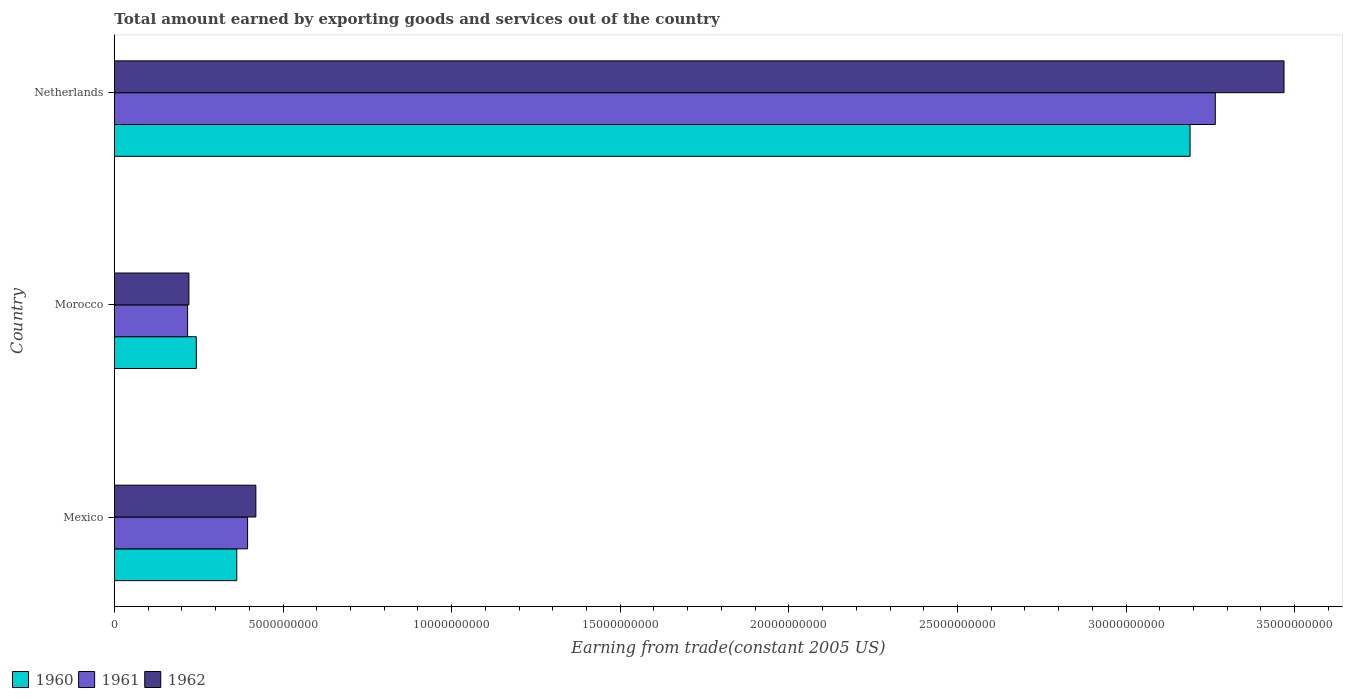How many groups of bars are there?
Ensure brevity in your answer.  3. Are the number of bars per tick equal to the number of legend labels?
Keep it short and to the point. Yes. How many bars are there on the 1st tick from the bottom?
Give a very brief answer. 3. What is the label of the 1st group of bars from the top?
Make the answer very short. Netherlands. In how many cases, is the number of bars for a given country not equal to the number of legend labels?
Offer a terse response. 0. What is the total amount earned by exporting goods and services in 1961 in Netherlands?
Your answer should be very brief. 3.26e+1. Across all countries, what is the maximum total amount earned by exporting goods and services in 1962?
Offer a terse response. 3.47e+1. Across all countries, what is the minimum total amount earned by exporting goods and services in 1960?
Ensure brevity in your answer.  2.43e+09. In which country was the total amount earned by exporting goods and services in 1960 minimum?
Your response must be concise. Morocco. What is the total total amount earned by exporting goods and services in 1961 in the graph?
Ensure brevity in your answer.  3.88e+1. What is the difference between the total amount earned by exporting goods and services in 1961 in Mexico and that in Netherlands?
Offer a terse response. -2.87e+1. What is the difference between the total amount earned by exporting goods and services in 1960 in Netherlands and the total amount earned by exporting goods and services in 1962 in Morocco?
Offer a terse response. 2.97e+1. What is the average total amount earned by exporting goods and services in 1962 per country?
Give a very brief answer. 1.37e+1. What is the difference between the total amount earned by exporting goods and services in 1960 and total amount earned by exporting goods and services in 1962 in Morocco?
Your response must be concise. 2.19e+08. In how many countries, is the total amount earned by exporting goods and services in 1960 greater than 23000000000 US$?
Offer a very short reply. 1. What is the ratio of the total amount earned by exporting goods and services in 1961 in Morocco to that in Netherlands?
Offer a very short reply. 0.07. Is the total amount earned by exporting goods and services in 1961 in Morocco less than that in Netherlands?
Your answer should be compact. Yes. Is the difference between the total amount earned by exporting goods and services in 1960 in Morocco and Netherlands greater than the difference between the total amount earned by exporting goods and services in 1962 in Morocco and Netherlands?
Give a very brief answer. Yes. What is the difference between the highest and the second highest total amount earned by exporting goods and services in 1962?
Your answer should be compact. 3.05e+1. What is the difference between the highest and the lowest total amount earned by exporting goods and services in 1960?
Make the answer very short. 2.95e+1. In how many countries, is the total amount earned by exporting goods and services in 1960 greater than the average total amount earned by exporting goods and services in 1960 taken over all countries?
Your response must be concise. 1. Is the sum of the total amount earned by exporting goods and services in 1960 in Morocco and Netherlands greater than the maximum total amount earned by exporting goods and services in 1961 across all countries?
Your answer should be compact. Yes. What does the 1st bar from the top in Morocco represents?
Offer a terse response. 1962. Is it the case that in every country, the sum of the total amount earned by exporting goods and services in 1960 and total amount earned by exporting goods and services in 1961 is greater than the total amount earned by exporting goods and services in 1962?
Provide a succinct answer. Yes. How many bars are there?
Offer a very short reply. 9. Are all the bars in the graph horizontal?
Your answer should be compact. Yes. Does the graph contain any zero values?
Make the answer very short. No. Does the graph contain grids?
Give a very brief answer. No. Where does the legend appear in the graph?
Your answer should be compact. Bottom left. How many legend labels are there?
Ensure brevity in your answer.  3. How are the legend labels stacked?
Make the answer very short. Horizontal. What is the title of the graph?
Make the answer very short. Total amount earned by exporting goods and services out of the country. Does "1992" appear as one of the legend labels in the graph?
Your answer should be very brief. No. What is the label or title of the X-axis?
Offer a terse response. Earning from trade(constant 2005 US). What is the label or title of the Y-axis?
Ensure brevity in your answer.  Country. What is the Earning from trade(constant 2005 US) in 1960 in Mexico?
Keep it short and to the point. 3.63e+09. What is the Earning from trade(constant 2005 US) in 1961 in Mexico?
Your response must be concise. 3.95e+09. What is the Earning from trade(constant 2005 US) of 1962 in Mexico?
Your answer should be compact. 4.19e+09. What is the Earning from trade(constant 2005 US) in 1960 in Morocco?
Your answer should be compact. 2.43e+09. What is the Earning from trade(constant 2005 US) of 1961 in Morocco?
Provide a short and direct response. 2.17e+09. What is the Earning from trade(constant 2005 US) in 1962 in Morocco?
Make the answer very short. 2.21e+09. What is the Earning from trade(constant 2005 US) in 1960 in Netherlands?
Keep it short and to the point. 3.19e+1. What is the Earning from trade(constant 2005 US) of 1961 in Netherlands?
Your answer should be compact. 3.26e+1. What is the Earning from trade(constant 2005 US) of 1962 in Netherlands?
Make the answer very short. 3.47e+1. Across all countries, what is the maximum Earning from trade(constant 2005 US) in 1960?
Offer a very short reply. 3.19e+1. Across all countries, what is the maximum Earning from trade(constant 2005 US) of 1961?
Make the answer very short. 3.26e+1. Across all countries, what is the maximum Earning from trade(constant 2005 US) in 1962?
Offer a very short reply. 3.47e+1. Across all countries, what is the minimum Earning from trade(constant 2005 US) of 1960?
Provide a succinct answer. 2.43e+09. Across all countries, what is the minimum Earning from trade(constant 2005 US) in 1961?
Your answer should be very brief. 2.17e+09. Across all countries, what is the minimum Earning from trade(constant 2005 US) of 1962?
Keep it short and to the point. 2.21e+09. What is the total Earning from trade(constant 2005 US) of 1960 in the graph?
Make the answer very short. 3.80e+1. What is the total Earning from trade(constant 2005 US) in 1961 in the graph?
Keep it short and to the point. 3.88e+1. What is the total Earning from trade(constant 2005 US) in 1962 in the graph?
Offer a very short reply. 4.11e+1. What is the difference between the Earning from trade(constant 2005 US) of 1960 in Mexico and that in Morocco?
Your answer should be very brief. 1.20e+09. What is the difference between the Earning from trade(constant 2005 US) in 1961 in Mexico and that in Morocco?
Ensure brevity in your answer.  1.78e+09. What is the difference between the Earning from trade(constant 2005 US) of 1962 in Mexico and that in Morocco?
Your response must be concise. 1.99e+09. What is the difference between the Earning from trade(constant 2005 US) in 1960 in Mexico and that in Netherlands?
Provide a succinct answer. -2.83e+1. What is the difference between the Earning from trade(constant 2005 US) in 1961 in Mexico and that in Netherlands?
Provide a succinct answer. -2.87e+1. What is the difference between the Earning from trade(constant 2005 US) of 1962 in Mexico and that in Netherlands?
Offer a terse response. -3.05e+1. What is the difference between the Earning from trade(constant 2005 US) of 1960 in Morocco and that in Netherlands?
Ensure brevity in your answer.  -2.95e+1. What is the difference between the Earning from trade(constant 2005 US) in 1961 in Morocco and that in Netherlands?
Offer a terse response. -3.05e+1. What is the difference between the Earning from trade(constant 2005 US) of 1962 in Morocco and that in Netherlands?
Provide a short and direct response. -3.25e+1. What is the difference between the Earning from trade(constant 2005 US) in 1960 in Mexico and the Earning from trade(constant 2005 US) in 1961 in Morocco?
Give a very brief answer. 1.46e+09. What is the difference between the Earning from trade(constant 2005 US) of 1960 in Mexico and the Earning from trade(constant 2005 US) of 1962 in Morocco?
Your answer should be very brief. 1.42e+09. What is the difference between the Earning from trade(constant 2005 US) of 1961 in Mexico and the Earning from trade(constant 2005 US) of 1962 in Morocco?
Offer a very short reply. 1.74e+09. What is the difference between the Earning from trade(constant 2005 US) of 1960 in Mexico and the Earning from trade(constant 2005 US) of 1961 in Netherlands?
Offer a very short reply. -2.90e+1. What is the difference between the Earning from trade(constant 2005 US) in 1960 in Mexico and the Earning from trade(constant 2005 US) in 1962 in Netherlands?
Provide a succinct answer. -3.11e+1. What is the difference between the Earning from trade(constant 2005 US) of 1961 in Mexico and the Earning from trade(constant 2005 US) of 1962 in Netherlands?
Ensure brevity in your answer.  -3.07e+1. What is the difference between the Earning from trade(constant 2005 US) of 1960 in Morocco and the Earning from trade(constant 2005 US) of 1961 in Netherlands?
Give a very brief answer. -3.02e+1. What is the difference between the Earning from trade(constant 2005 US) in 1960 in Morocco and the Earning from trade(constant 2005 US) in 1962 in Netherlands?
Give a very brief answer. -3.23e+1. What is the difference between the Earning from trade(constant 2005 US) of 1961 in Morocco and the Earning from trade(constant 2005 US) of 1962 in Netherlands?
Ensure brevity in your answer.  -3.25e+1. What is the average Earning from trade(constant 2005 US) in 1960 per country?
Your answer should be very brief. 1.27e+1. What is the average Earning from trade(constant 2005 US) in 1961 per country?
Make the answer very short. 1.29e+1. What is the average Earning from trade(constant 2005 US) in 1962 per country?
Offer a very short reply. 1.37e+1. What is the difference between the Earning from trade(constant 2005 US) in 1960 and Earning from trade(constant 2005 US) in 1961 in Mexico?
Give a very brief answer. -3.21e+08. What is the difference between the Earning from trade(constant 2005 US) in 1960 and Earning from trade(constant 2005 US) in 1962 in Mexico?
Your answer should be very brief. -5.66e+08. What is the difference between the Earning from trade(constant 2005 US) of 1961 and Earning from trade(constant 2005 US) of 1962 in Mexico?
Your answer should be very brief. -2.45e+08. What is the difference between the Earning from trade(constant 2005 US) in 1960 and Earning from trade(constant 2005 US) in 1961 in Morocco?
Offer a very short reply. 2.59e+08. What is the difference between the Earning from trade(constant 2005 US) of 1960 and Earning from trade(constant 2005 US) of 1962 in Morocco?
Give a very brief answer. 2.19e+08. What is the difference between the Earning from trade(constant 2005 US) of 1961 and Earning from trade(constant 2005 US) of 1962 in Morocco?
Provide a succinct answer. -3.93e+07. What is the difference between the Earning from trade(constant 2005 US) in 1960 and Earning from trade(constant 2005 US) in 1961 in Netherlands?
Ensure brevity in your answer.  -7.48e+08. What is the difference between the Earning from trade(constant 2005 US) in 1960 and Earning from trade(constant 2005 US) in 1962 in Netherlands?
Make the answer very short. -2.79e+09. What is the difference between the Earning from trade(constant 2005 US) in 1961 and Earning from trade(constant 2005 US) in 1962 in Netherlands?
Your answer should be compact. -2.04e+09. What is the ratio of the Earning from trade(constant 2005 US) of 1960 in Mexico to that in Morocco?
Make the answer very short. 1.49. What is the ratio of the Earning from trade(constant 2005 US) in 1961 in Mexico to that in Morocco?
Provide a succinct answer. 1.82. What is the ratio of the Earning from trade(constant 2005 US) in 1962 in Mexico to that in Morocco?
Give a very brief answer. 1.9. What is the ratio of the Earning from trade(constant 2005 US) in 1960 in Mexico to that in Netherlands?
Your answer should be compact. 0.11. What is the ratio of the Earning from trade(constant 2005 US) of 1961 in Mexico to that in Netherlands?
Make the answer very short. 0.12. What is the ratio of the Earning from trade(constant 2005 US) in 1962 in Mexico to that in Netherlands?
Give a very brief answer. 0.12. What is the ratio of the Earning from trade(constant 2005 US) of 1960 in Morocco to that in Netherlands?
Offer a terse response. 0.08. What is the ratio of the Earning from trade(constant 2005 US) in 1961 in Morocco to that in Netherlands?
Your answer should be very brief. 0.07. What is the ratio of the Earning from trade(constant 2005 US) of 1962 in Morocco to that in Netherlands?
Keep it short and to the point. 0.06. What is the difference between the highest and the second highest Earning from trade(constant 2005 US) in 1960?
Your answer should be compact. 2.83e+1. What is the difference between the highest and the second highest Earning from trade(constant 2005 US) of 1961?
Your answer should be very brief. 2.87e+1. What is the difference between the highest and the second highest Earning from trade(constant 2005 US) of 1962?
Your answer should be compact. 3.05e+1. What is the difference between the highest and the lowest Earning from trade(constant 2005 US) of 1960?
Provide a succinct answer. 2.95e+1. What is the difference between the highest and the lowest Earning from trade(constant 2005 US) in 1961?
Ensure brevity in your answer.  3.05e+1. What is the difference between the highest and the lowest Earning from trade(constant 2005 US) of 1962?
Ensure brevity in your answer.  3.25e+1. 